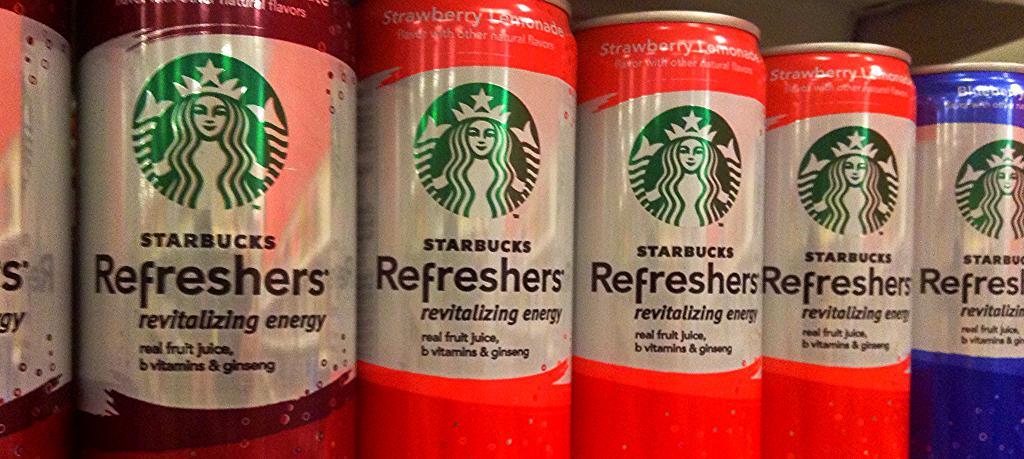Which national coffee chain sells these beverages?
Your answer should be compact. Starbucks. 